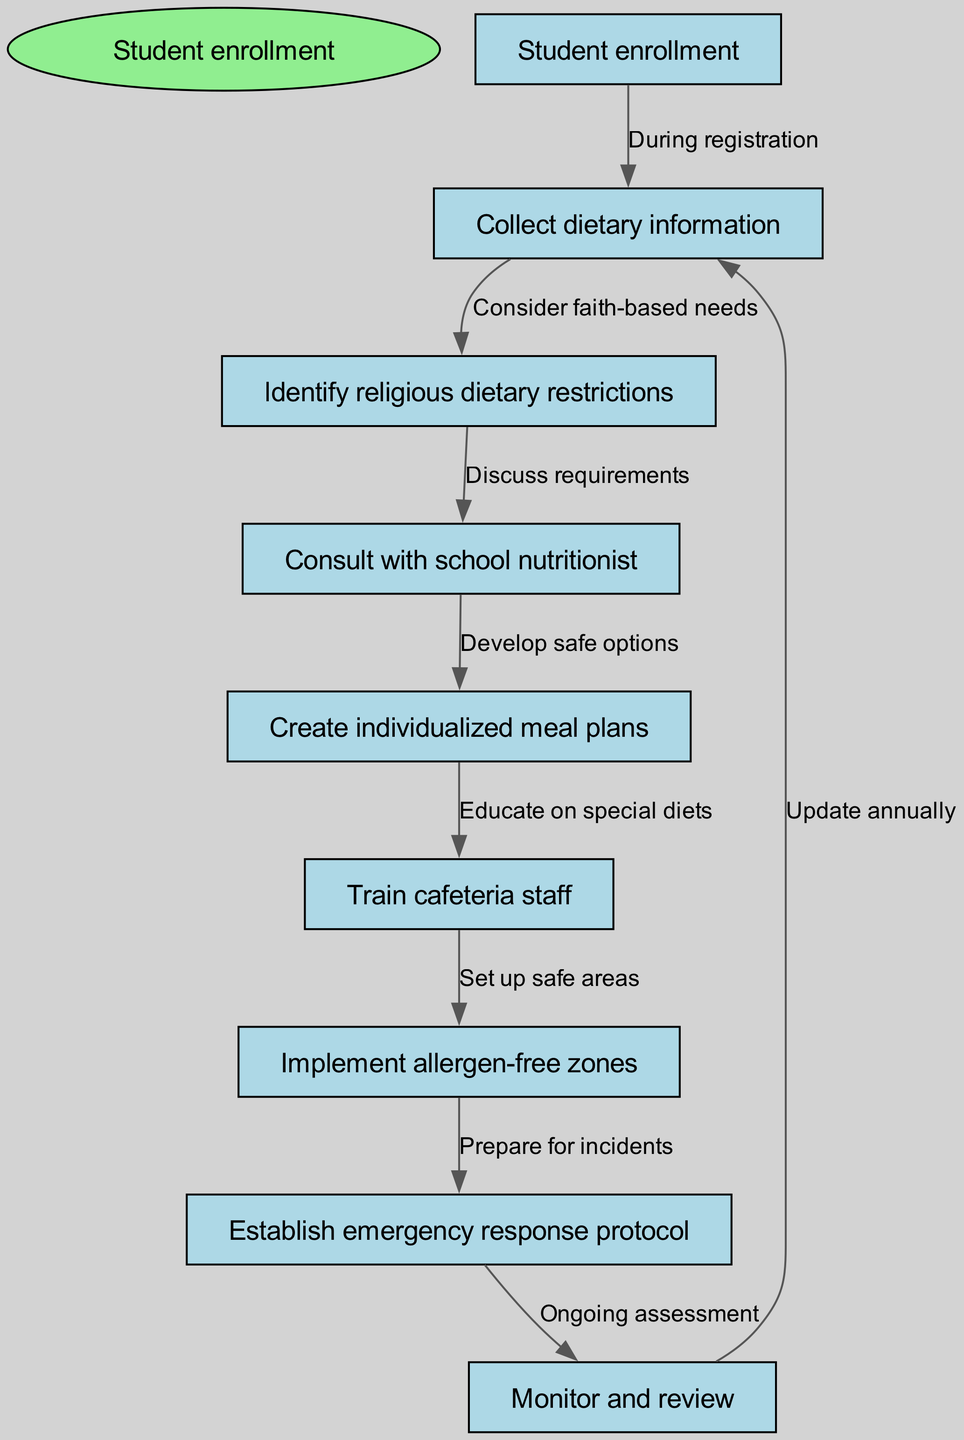What is the starting point of the clinical pathway? The starting point is identified in the diagram as "Student enrollment," which is indicated at the top as the initial node before any other processes begin.
Answer: Student enrollment How many nodes are present in the pathway? By counting all the distinct locations in the diagram, including the start node and all other nodes, it is determined that there are eight nodes in total.
Answer: 8 What is the relationship between "Collect dietary information" and "Identify religious dietary restrictions"? The diagram shows that "Collect dietary information" directly leads to "Identify religious dietary restrictions," highlighting that dietary information collection considers faith-based needs.
Answer: Consider faith-based needs Which node comes after "Consult with school nutritionist"? The diagram flows from "Consult with school nutritionist" directly to "Create individualized meal plans," indicating this is the subsequent step in the process.
Answer: Create individualized meal plans What is established after "Implement allergen-free zones"? As depicted in the diagram, following "Implement allergen-free zones," the next step is to "Establish emergency response protocol," indicating the relationship between these two nodes.
Answer: Establish emergency response protocol What is a recurring process at the end of the pathway? The pathway indicates that there is a loop where "Monitor and review" leads back to "Collect dietary information," which signifies an ongoing assessment to update dietary needs and restrictions annually.
Answer: Update annually What does the node "Train cafeteria staff" lead to? The flow in the diagram shows that "Train cafeteria staff" leads to "Implement allergen-free zones," meaning that staff training is necessary before creating allergen-free areas in the cafeteria.
Answer: Implement allergen-free zones What is the purpose of the node "Establish emergency response protocol"? The purpose of "Establish emergency response protocol" in the diagram is to prepare for incidents that may arise related to food allergies or dietary restrictions, ensuring safety measures are in place.
Answer: Prepare for incidents What is discussed in the consultation with the school nutritionist? The relationship depicted in the diagram indicates that during consultation, there is a discussion about dietary requirements, focusing on how to meet the needs of students with dietary restrictions.
Answer: Discuss requirements 